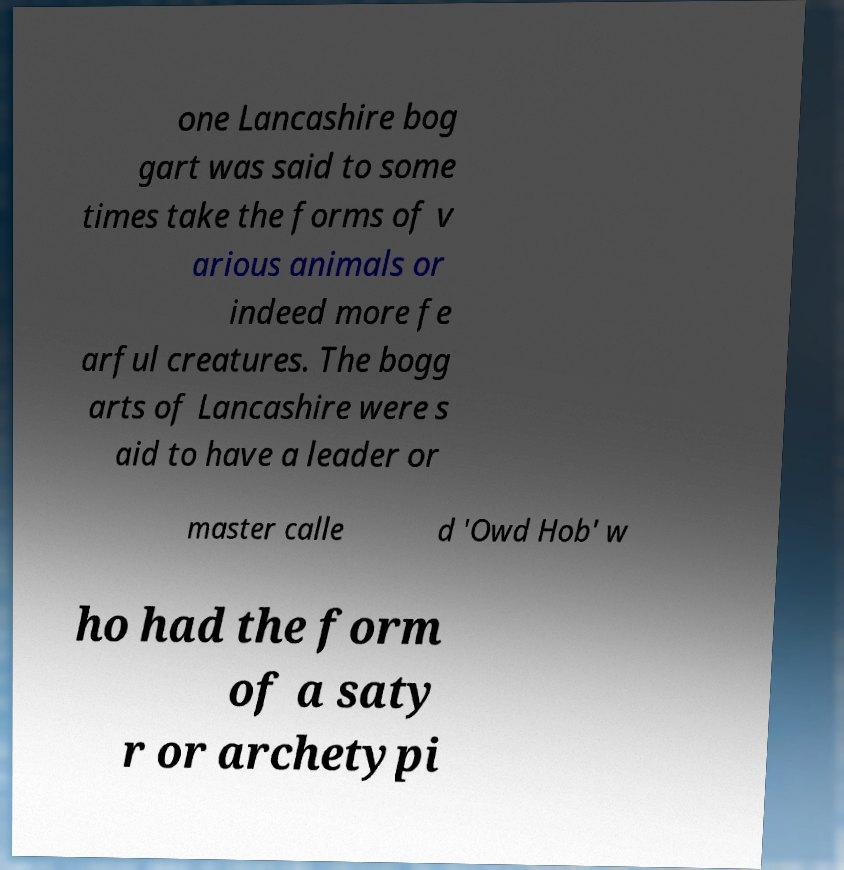I need the written content from this picture converted into text. Can you do that? one Lancashire bog gart was said to some times take the forms of v arious animals or indeed more fe arful creatures. The bogg arts of Lancashire were s aid to have a leader or master calle d 'Owd Hob' w ho had the form of a saty r or archetypi 